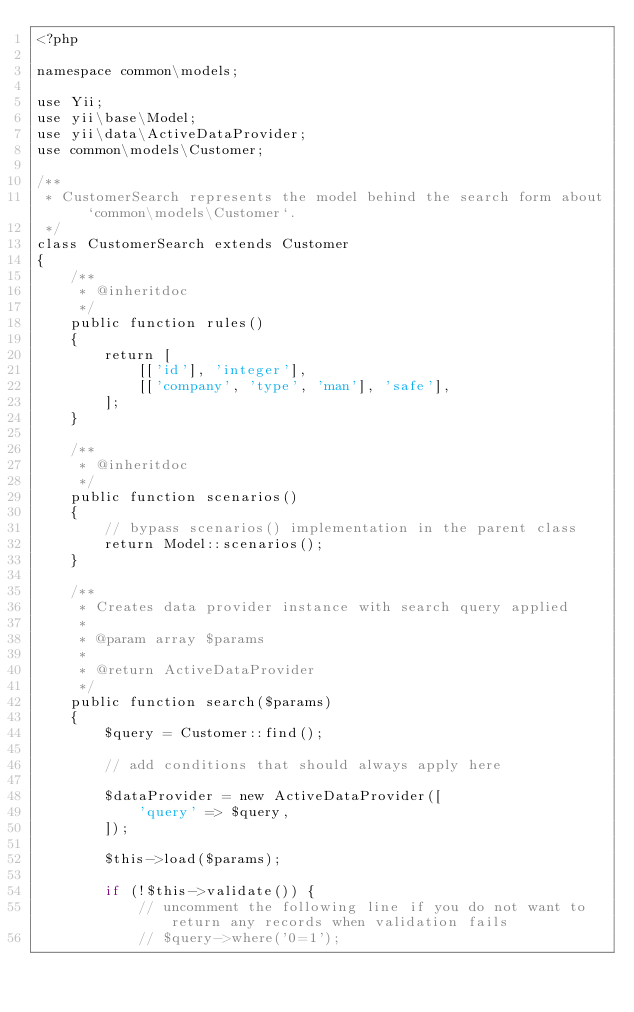Convert code to text. <code><loc_0><loc_0><loc_500><loc_500><_PHP_><?php

namespace common\models;

use Yii;
use yii\base\Model;
use yii\data\ActiveDataProvider;
use common\models\Customer;

/**
 * CustomerSearch represents the model behind the search form about `common\models\Customer`.
 */
class CustomerSearch extends Customer
{
    /**
     * @inheritdoc
     */
    public function rules()
    {
        return [
            [['id'], 'integer'],
            [['company', 'type', 'man'], 'safe'],
        ];
    }

    /**
     * @inheritdoc
     */
    public function scenarios()
    {
        // bypass scenarios() implementation in the parent class
        return Model::scenarios();
    }

    /**
     * Creates data provider instance with search query applied
     *
     * @param array $params
     *
     * @return ActiveDataProvider
     */
    public function search($params)
    {
        $query = Customer::find();

        // add conditions that should always apply here

        $dataProvider = new ActiveDataProvider([
            'query' => $query,
        ]);

        $this->load($params);

        if (!$this->validate()) {
            // uncomment the following line if you do not want to return any records when validation fails
            // $query->where('0=1');</code> 